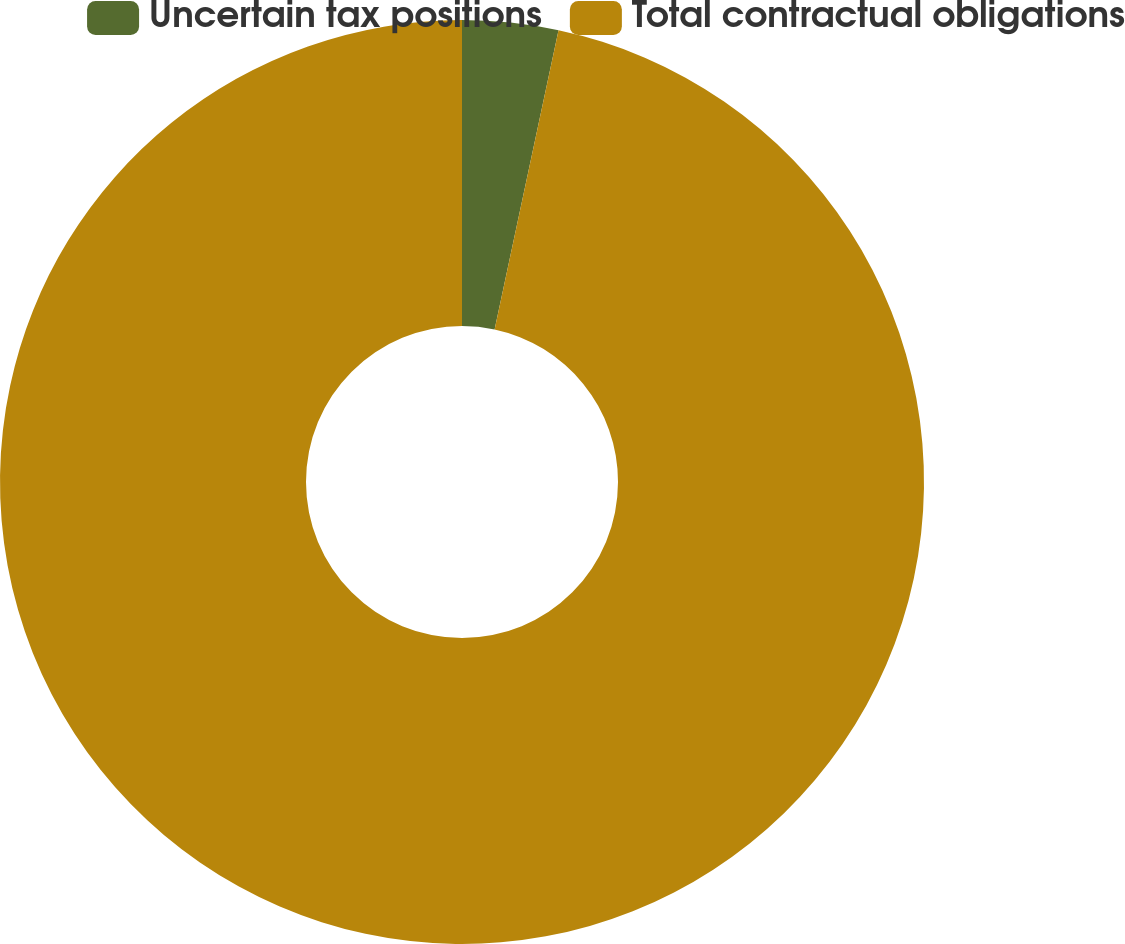Convert chart. <chart><loc_0><loc_0><loc_500><loc_500><pie_chart><fcel>Uncertain tax positions<fcel>Total contractual obligations<nl><fcel>3.35%<fcel>96.65%<nl></chart> 